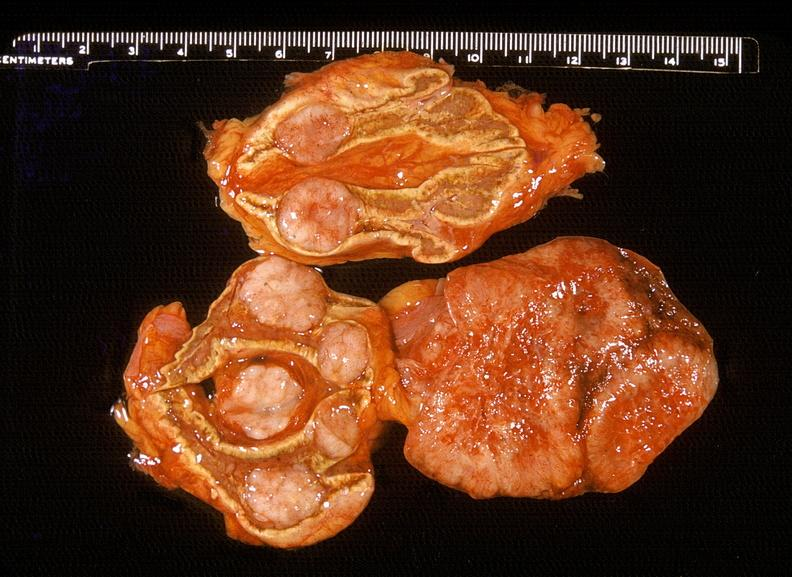does myocardial infarct show adrenal, metastatic lung carcinoma?
Answer the question using a single word or phrase. No 